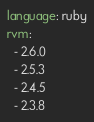<code> <loc_0><loc_0><loc_500><loc_500><_YAML_>language: ruby
rvm:
  - 2.6.0
  - 2.5.3
  - 2.4.5
  - 2.3.8
</code> 